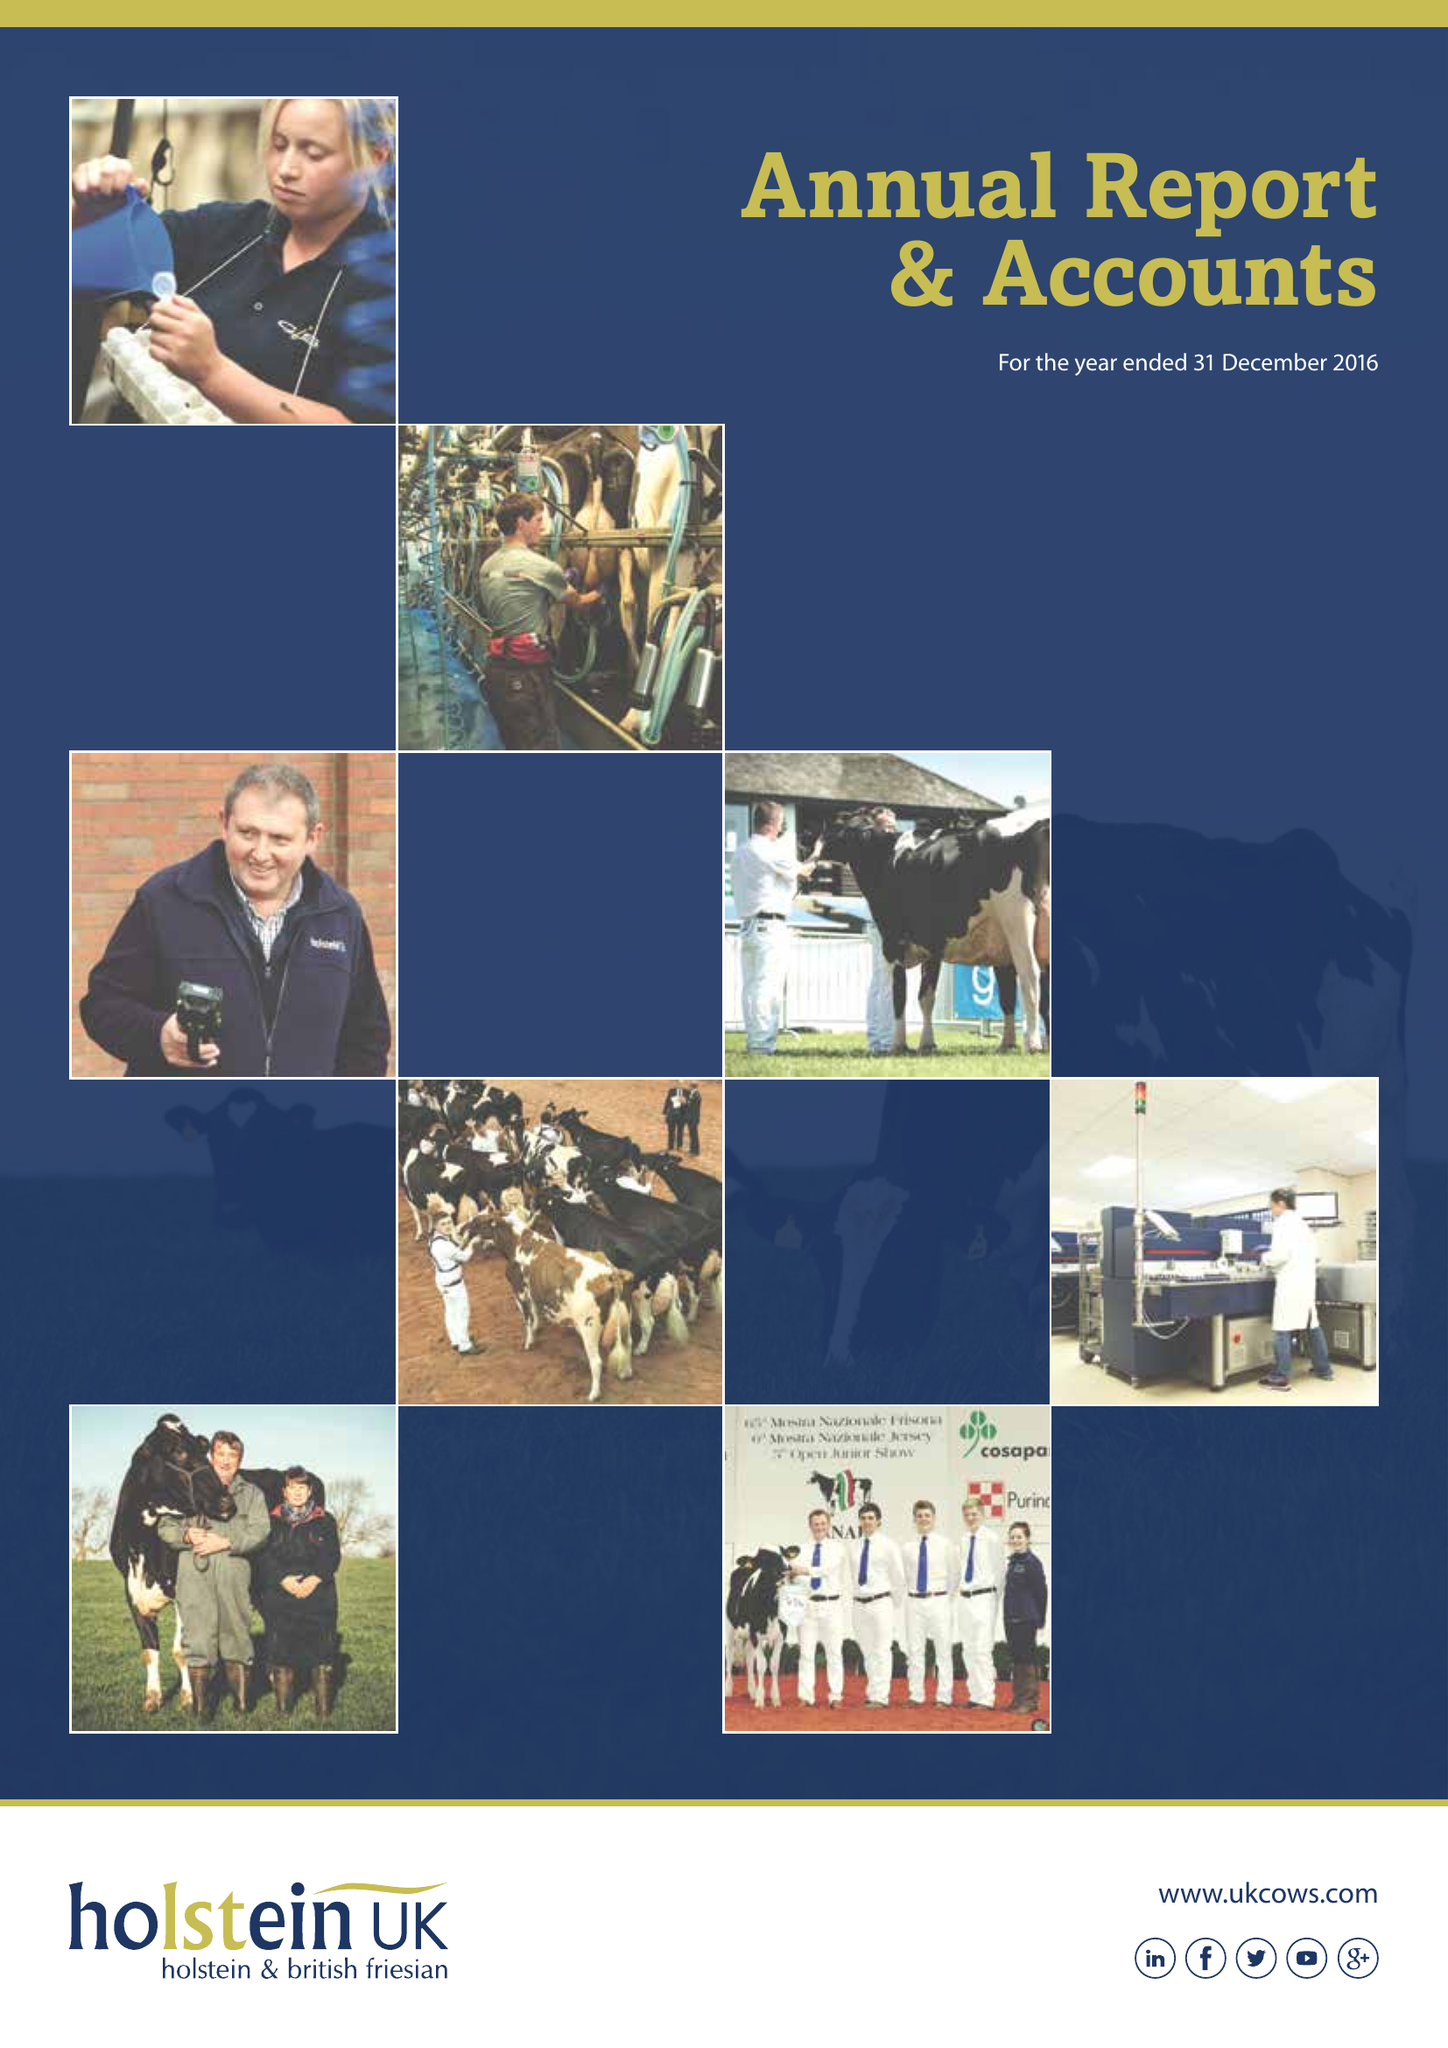What is the value for the spending_annually_in_british_pounds?
Answer the question using a single word or phrase. 9590679.00 